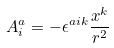<formula> <loc_0><loc_0><loc_500><loc_500>A ^ { a } _ { i } = - \epsilon ^ { a i k } \frac { x ^ { k } } { r ^ { 2 } }</formula> 